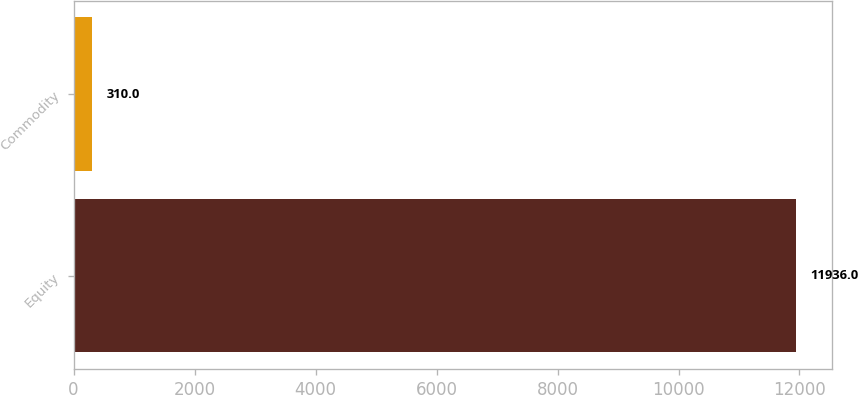Convert chart to OTSL. <chart><loc_0><loc_0><loc_500><loc_500><bar_chart><fcel>Equity<fcel>Commodity<nl><fcel>11936<fcel>310<nl></chart> 